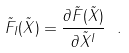Convert formula to latex. <formula><loc_0><loc_0><loc_500><loc_500>\tilde { F } _ { I } ( \tilde { X } ) = \frac { \partial \tilde { F } ( \tilde { X } ) } { \partial \tilde { X } ^ { I } } \ .</formula> 